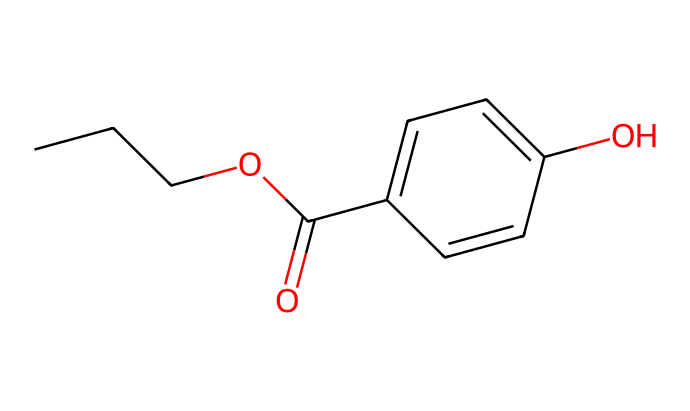What is the general chemical class of propylparaben? This chemical contains a benzoate structure due to the aromatic ring, combined with a propyl group and an ester functional group, positioning it in the class of parabens, which are commonly used as emulsifiers and preservatives in cosmetics.
Answer: paraben How many carbon atoms are in propylparaben? By analyzing the SMILES representation, we can count the total number of carbon atoms. There are a three-carbon propyl group and a six-membered aromatic ring contributing to a total of nine carbon atoms.
Answer: 9 How many aromatic rings does propylparaben have? Upon examining the chemical structure presented in the SMILES notation, it is clear there is one aromatic ring present in the compound, which classifies it as having an aromatic character.
Answer: 1 What functional group is responsible for the preservative properties of propylparaben? The ester functional group present within the structure enables it to act as a preservative, which prevents microbial growth and extends the shelf life of cosmetic products.
Answer: ester What is the molecular formula of propylparaben? To derive the molecular formula, we can identify the counts of carbon, hydrogen, and oxygen atoms from the SMILES: C9H10O3, which reflects the composition of the molecule accurately.
Answer: C9H10O3 What is the position of the hydroxyl group in propylparaben? The SMILES indicates a hydroxyl group (-OH) is attached to the benzene ring, specifically at the para position relative to the carboxylate moiety, making it essential for the compound's activity.
Answer: para 